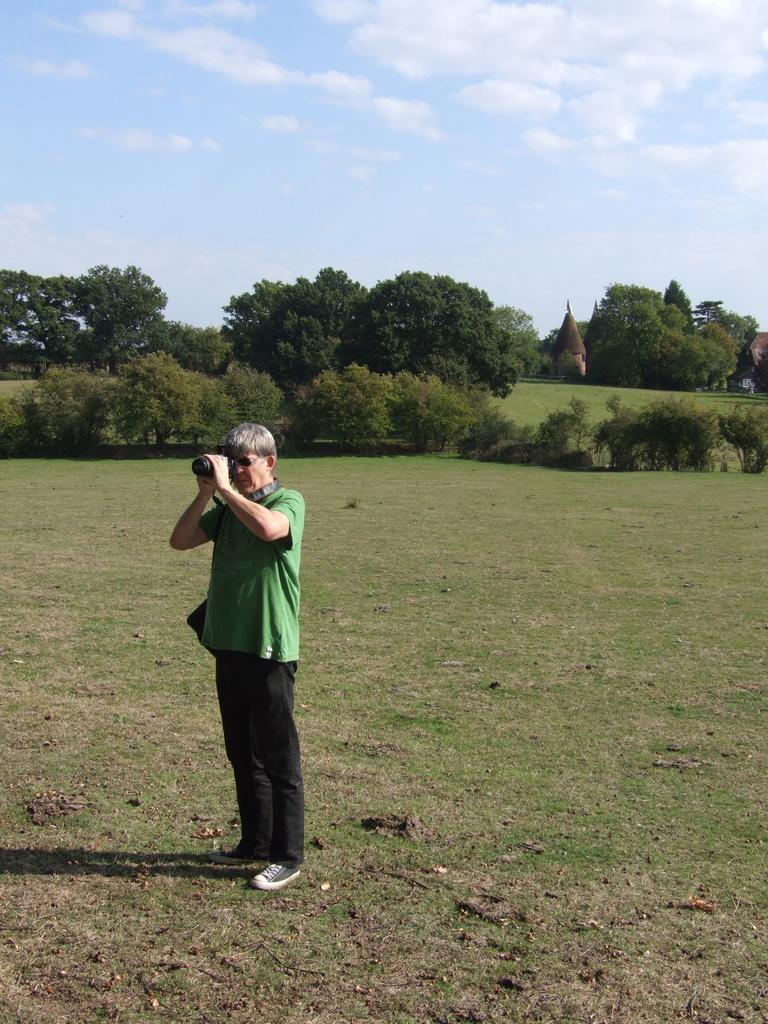What is the main subject of the image? The main subject of the image is a man. What is the man doing in the image? The man is standing in the image. What is the man holding in his hand? The man is holding a camera in his hand. What can be seen in the background of the image? There are trees, grass, and the sky visible in the background of the image. What book is the man reading in the image? The image does not show the man reading a book; he is holding a camera instead. How many feet can be seen in the image? There are no feet visible in the image; it only shows a man holding a camera. 